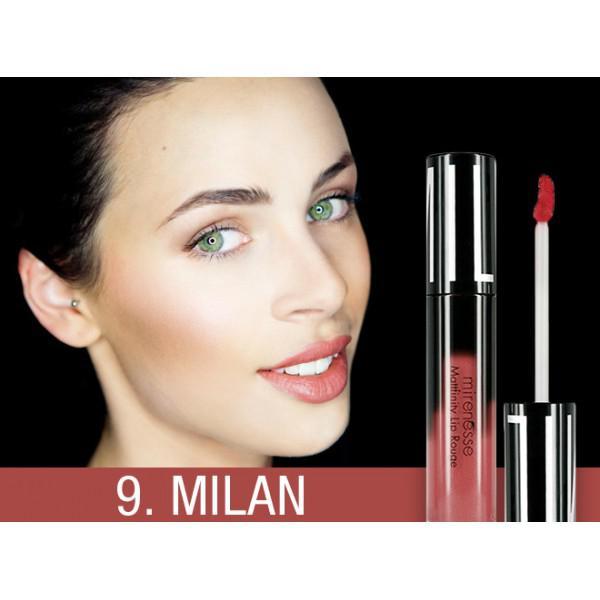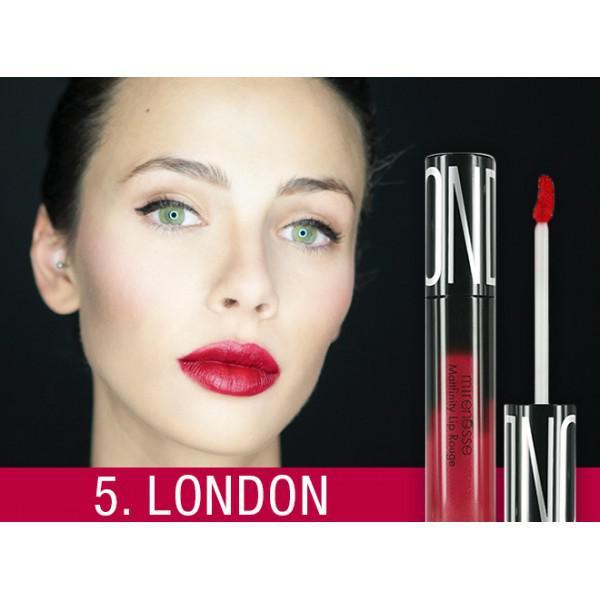The first image is the image on the left, the second image is the image on the right. Given the left and right images, does the statement "The woman's lips are closed in the image on the right." hold true? Answer yes or no. Yes. The first image is the image on the left, the second image is the image on the right. Assess this claim about the two images: "One image shows a model with tinted lips that are closed, so no teeth show.". Correct or not? Answer yes or no. Yes. 